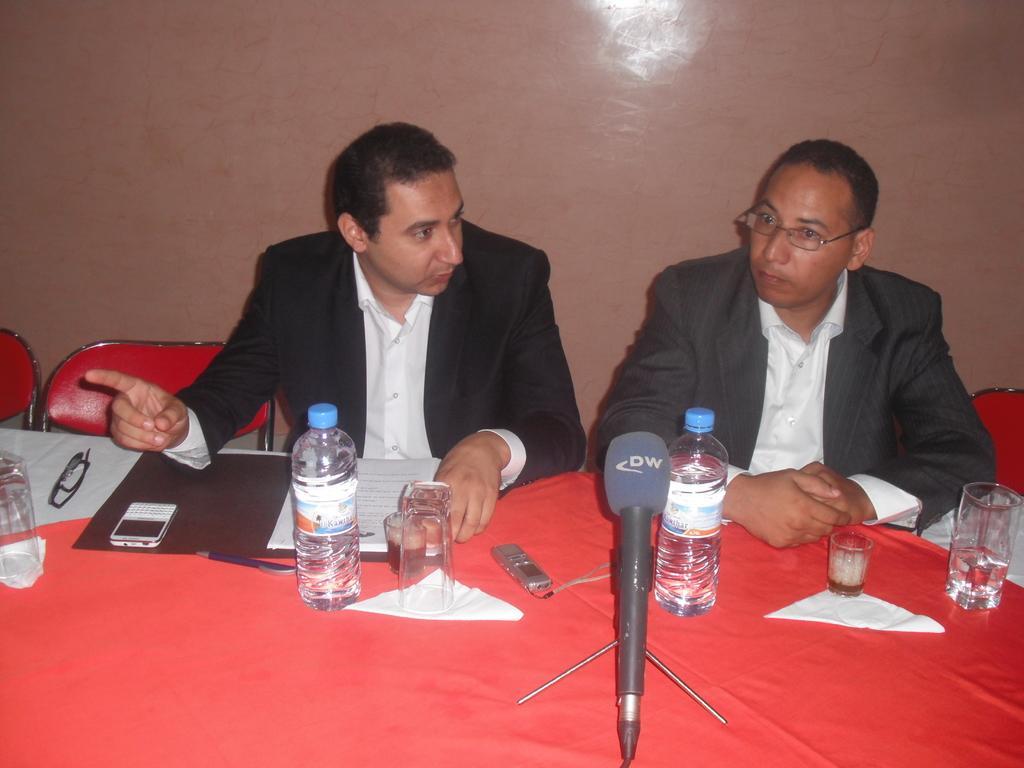Could you give a brief overview of what you see in this image? In this image, there are two person sitting on the chair in front of the table on which milk, bottle, glass, mobile, specs etc., are kept. And they are wearing a black color suit. The background wall is light pink in color. This image is taken inside a room. 